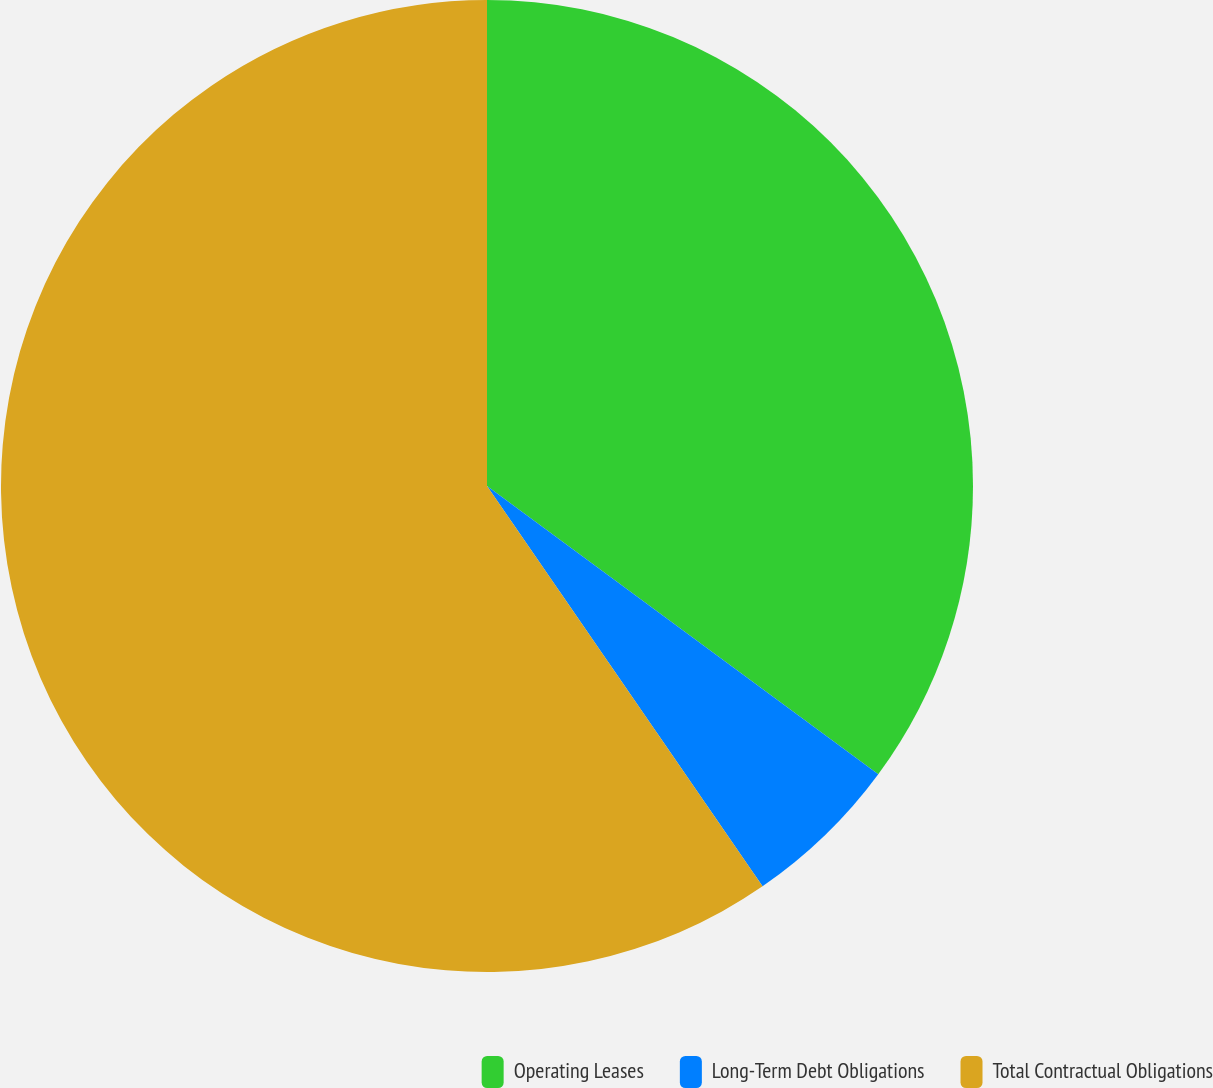Convert chart to OTSL. <chart><loc_0><loc_0><loc_500><loc_500><pie_chart><fcel>Operating Leases<fcel>Long-Term Debt Obligations<fcel>Total Contractual Obligations<nl><fcel>35.11%<fcel>5.3%<fcel>59.6%<nl></chart> 